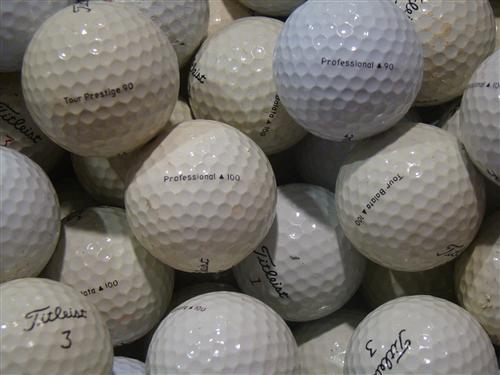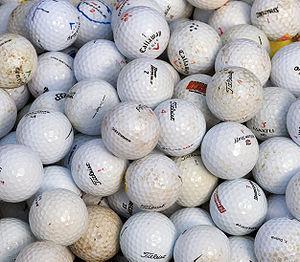The first image is the image on the left, the second image is the image on the right. Given the left and right images, does the statement "The balls in the image on the right are in bright light." hold true? Answer yes or no. Yes. 